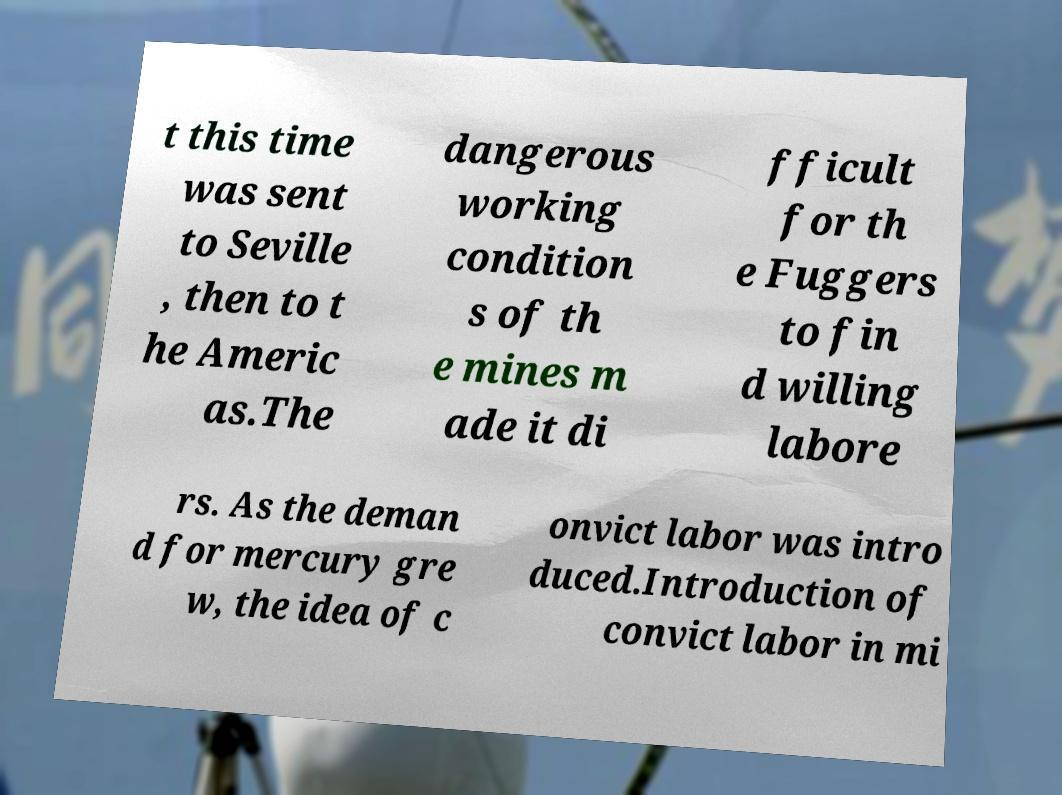Please identify and transcribe the text found in this image. t this time was sent to Seville , then to t he Americ as.The dangerous working condition s of th e mines m ade it di fficult for th e Fuggers to fin d willing labore rs. As the deman d for mercury gre w, the idea of c onvict labor was intro duced.Introduction of convict labor in mi 